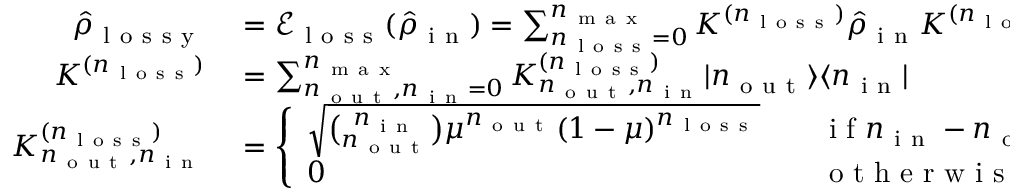<formula> <loc_0><loc_0><loc_500><loc_500>\begin{array} { r l } { \hat { \rho } _ { l o s s y } } & = \ m a t h s c r { E } _ { l o s s } ( \hat { \rho } _ { i n } ) = \sum _ { n _ { l o s s } = 0 } ^ { n _ { m a x } } K ^ { ( n _ { l o s s } ) } \hat { \rho } _ { i n } K ^ { ( n _ { l o s s } ) \dag } , } \\ { K ^ { ( n _ { l o s s } ) } } & = \sum _ { n _ { o u t } , n _ { i n } = 0 } ^ { n _ { m a x } } K _ { n _ { o u t } , n _ { i n } } ^ { ( n _ { l o s s } ) } | n _ { o u t } \rangle \langle n _ { i n } | } \\ { K _ { n _ { o u t } , n _ { i n } } ^ { ( n _ { l o s s } ) } } & = \left \{ \begin{array} { l l } { \sqrt { \binom { n _ { i n } } { n _ { o u t } } \mu ^ { n _ { o u t } } ( 1 - \mu ) ^ { n _ { l o s s } } } } & { \quad i f n _ { i n } - n _ { o u t } = n _ { l o s s } } \\ { 0 } & { \quad o t h e r w i s e , } \end{array} } \end{array}</formula> 